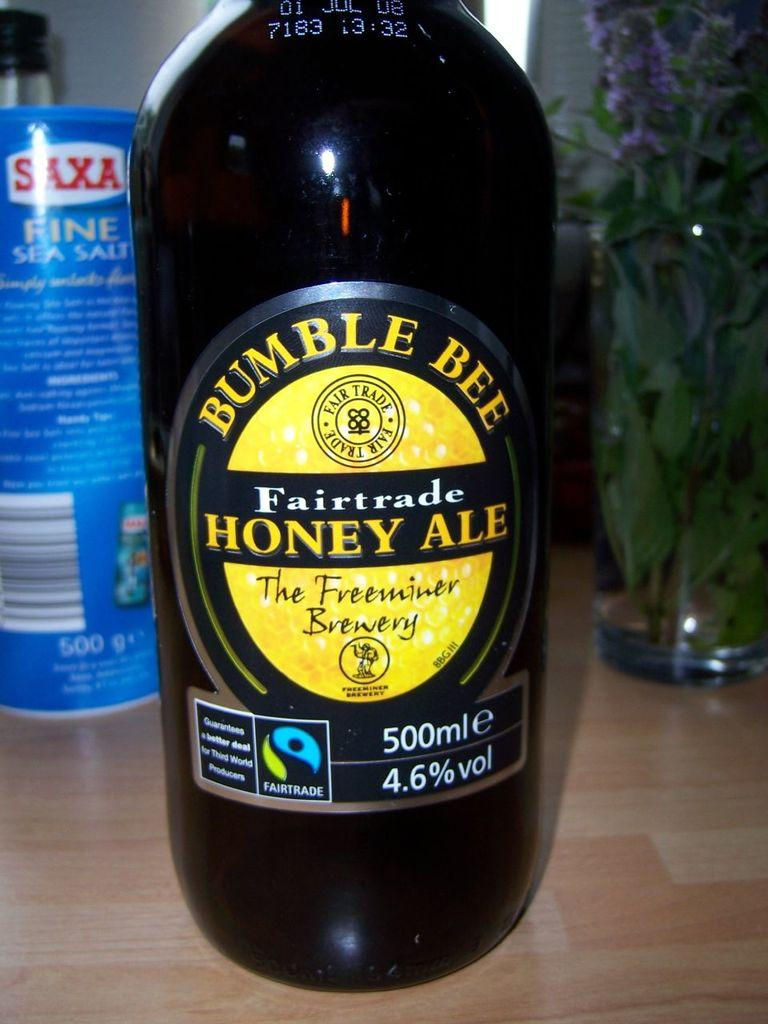<image>
Summarize the visual content of the image. a 500ml bottle of bumble bee fairtrade honey ale 